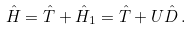Convert formula to latex. <formula><loc_0><loc_0><loc_500><loc_500>\hat { H } = \hat { T } + \hat { H } _ { 1 } = \hat { T } + U \hat { D } \, .</formula> 